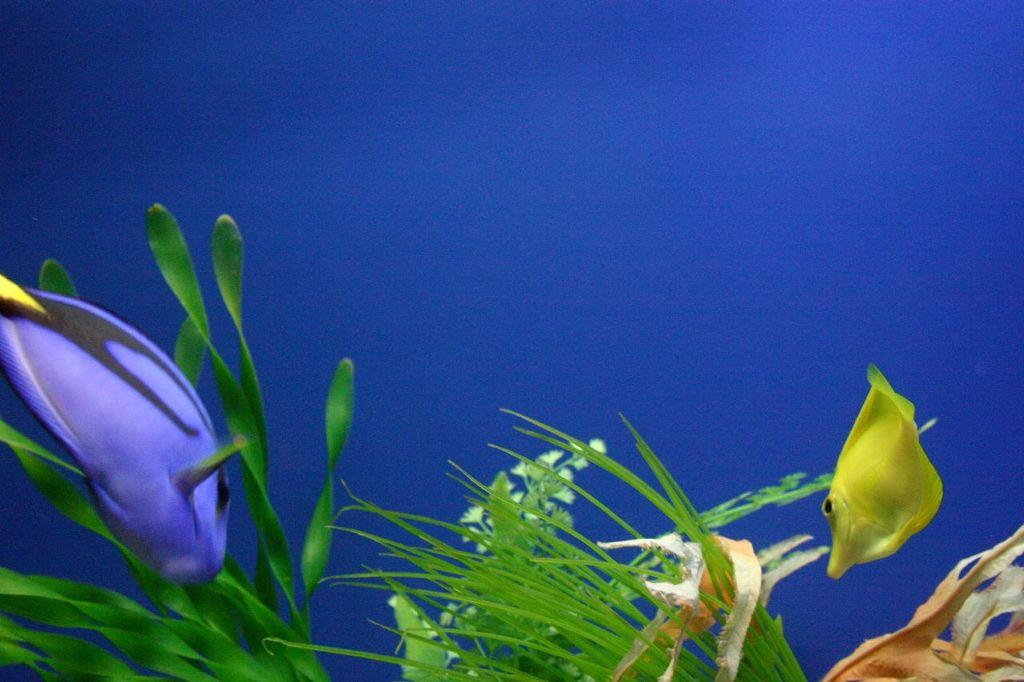What type of animals are in the image? There are two fish in the image, one yellow and one violet. What are the fish positioned in front of? The fish are before plants with flowers. What color is the background of the image? The background of the image is blue. Can you see any cattle grazing in the image? There are no cattle present in the image; it features fish and plants with flowers. What direction is the wind blowing in the image? There is no wind present in the image, as it is focused on the fish and plants with flowers. 